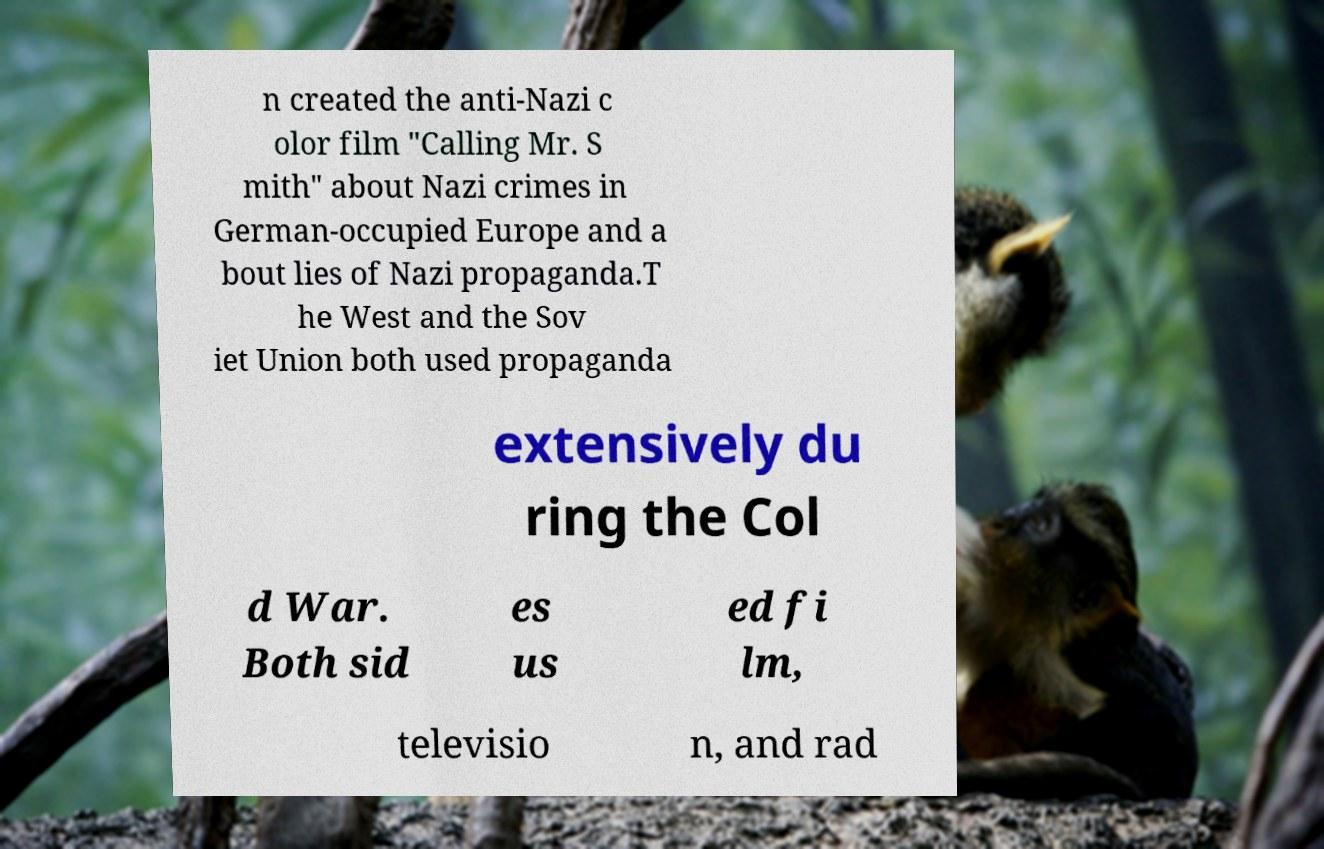Could you extract and type out the text from this image? n created the anti-Nazi c olor film "Calling Mr. S mith" about Nazi crimes in German-occupied Europe and a bout lies of Nazi propaganda.T he West and the Sov iet Union both used propaganda extensively du ring the Col d War. Both sid es us ed fi lm, televisio n, and rad 